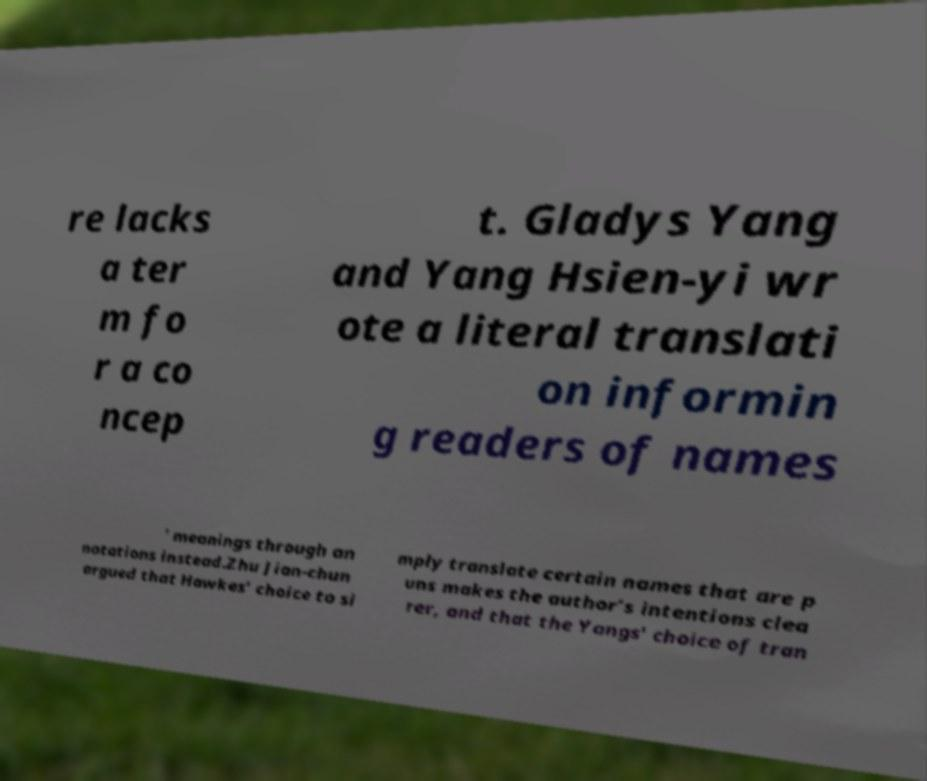Can you accurately transcribe the text from the provided image for me? re lacks a ter m fo r a co ncep t. Gladys Yang and Yang Hsien-yi wr ote a literal translati on informin g readers of names ' meanings through an notations instead.Zhu Jian-chun argued that Hawkes’ choice to si mply translate certain names that are p uns makes the author’s intentions clea rer, and that the Yangs' choice of tran 